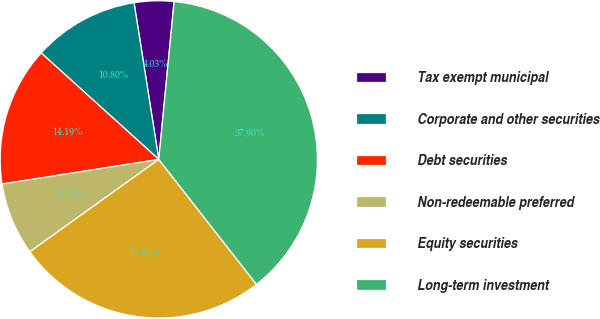<chart> <loc_0><loc_0><loc_500><loc_500><pie_chart><fcel>Tax exempt municipal<fcel>Corporate and other securities<fcel>Debt securities<fcel>Non-redeemable preferred<fcel>Equity securities<fcel>Long-term investment<nl><fcel>4.03%<fcel>10.8%<fcel>14.19%<fcel>7.41%<fcel>25.67%<fcel>37.9%<nl></chart> 